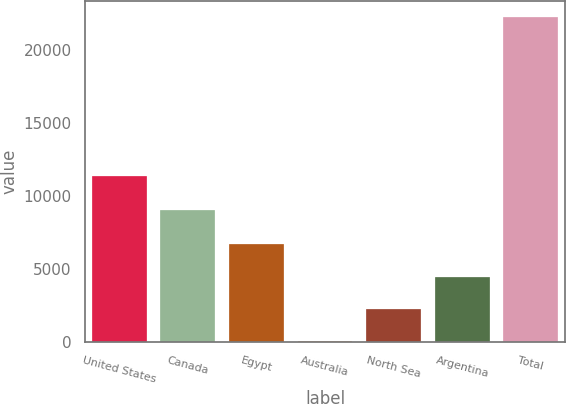<chart> <loc_0><loc_0><loc_500><loc_500><bar_chart><fcel>United States<fcel>Canada<fcel>Egypt<fcel>Australia<fcel>North Sea<fcel>Argentina<fcel>Total<nl><fcel>11364<fcel>9030<fcel>6701.1<fcel>27<fcel>2251.7<fcel>4476.4<fcel>22274<nl></chart> 